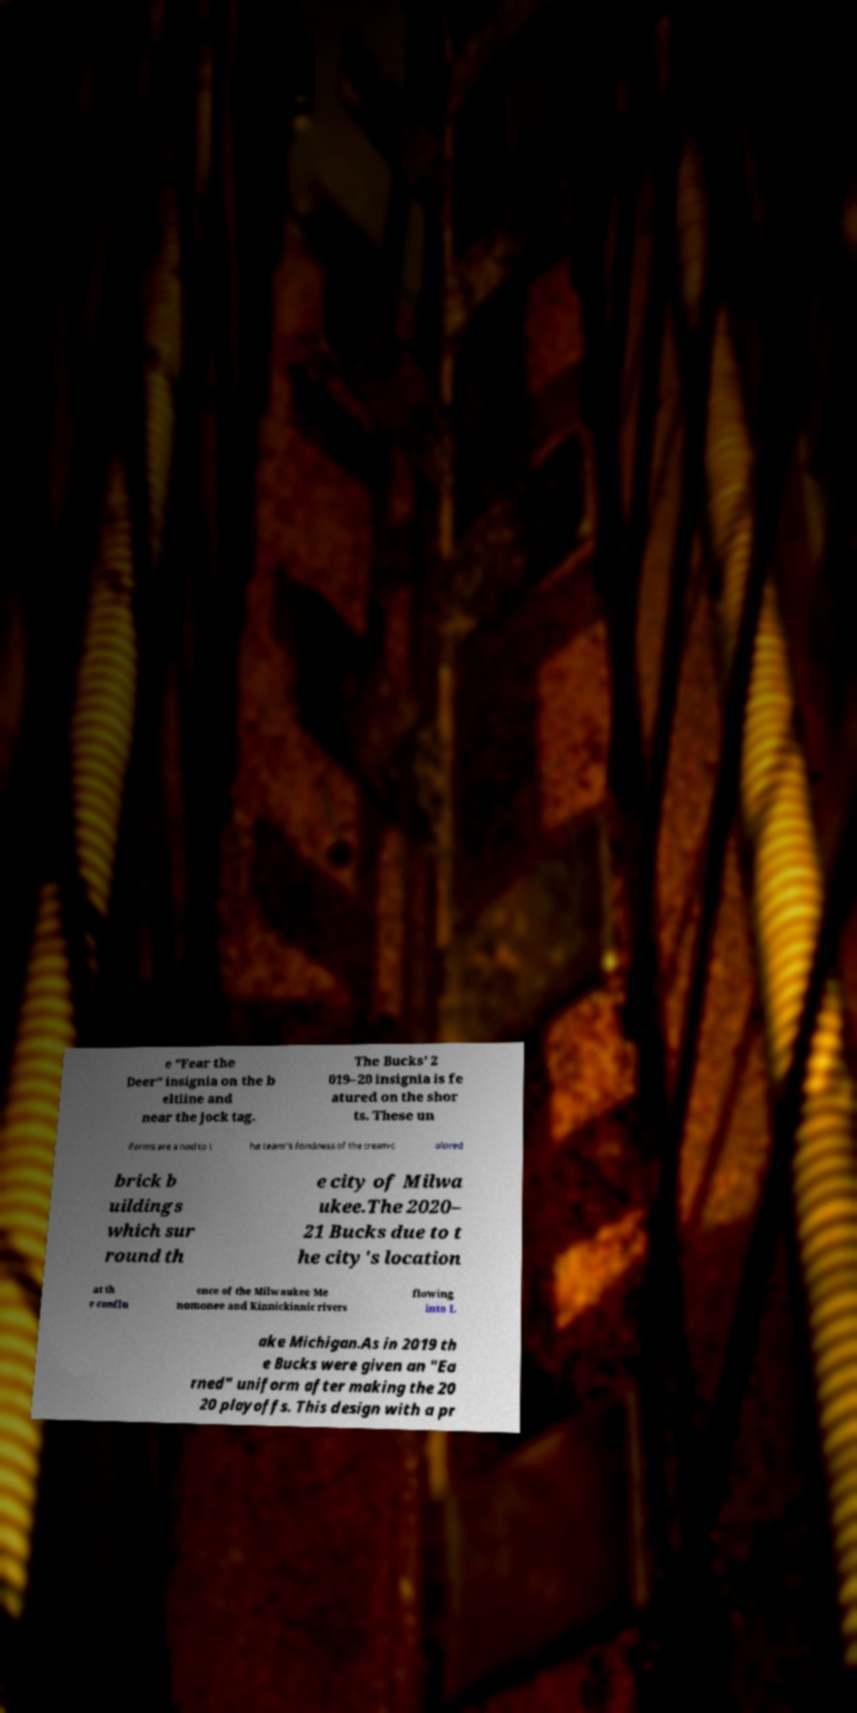For documentation purposes, I need the text within this image transcribed. Could you provide that? e "Fear the Deer" insignia on the b eltline and near the jock tag. The Bucks' 2 019–20 insignia is fe atured on the shor ts. These un iforms are a nod to t he team’s fondness of the cream-c olored brick b uildings which sur round th e city of Milwa ukee.The 2020– 21 Bucks due to t he city's location at th e conflu ence of the Milwaukee Me nomonee and Kinnickinnic rivers flowing into L ake Michigan.As in 2019 th e Bucks were given an "Ea rned" uniform after making the 20 20 playoffs. This design with a pr 